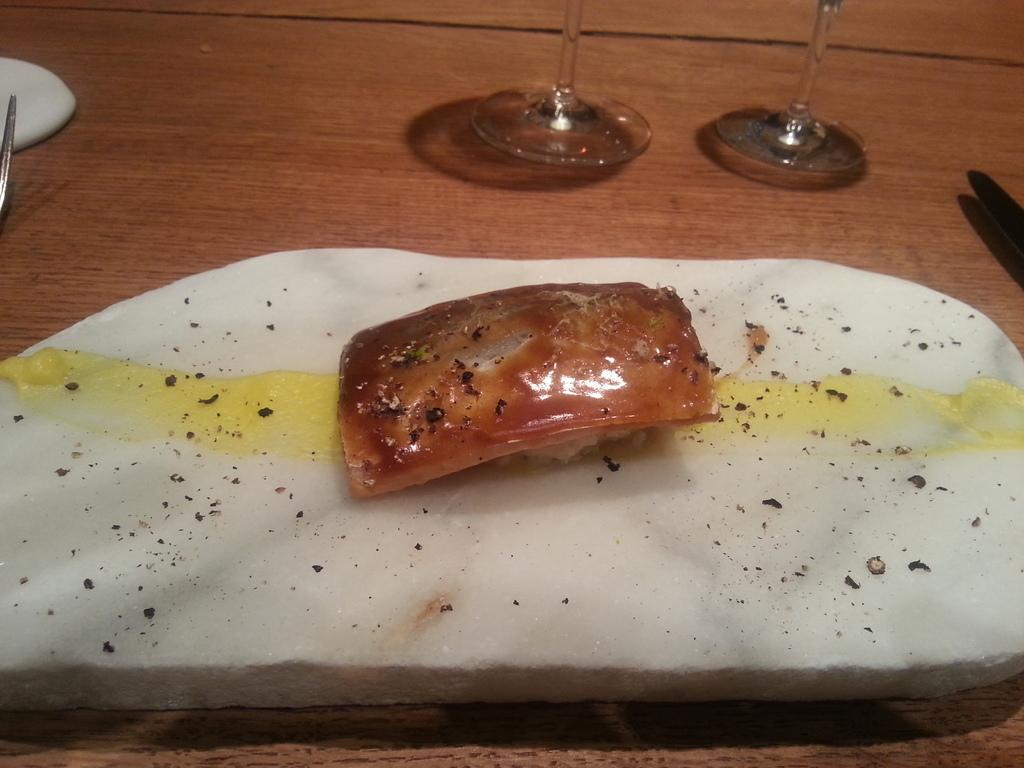What is the main subject in the center of the image? There is a kasuzuke in the center of the image. What objects can be seen at the top side of the image? There are glasses at the top side of the image. What utensil is located on the left side of the image? There is a fork on the left side of the image. Can you see any animals from the zoo in the image? There is no reference to a zoo or any animals in the image, so it's not possible to determine if any animals from a zoo are present. 